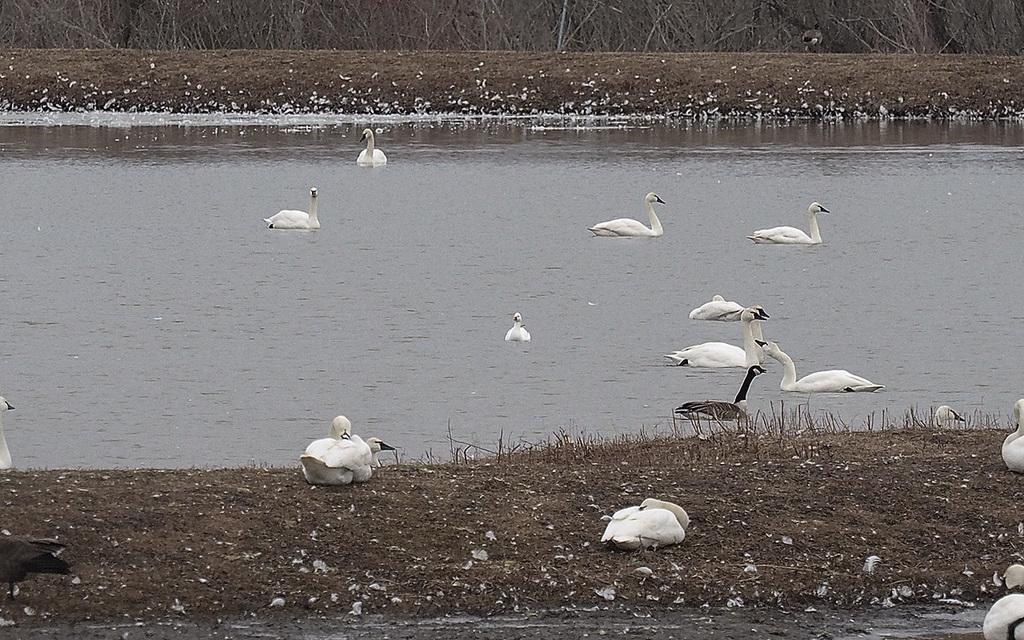In one or two sentences, can you explain what this image depicts? In this image I can see the birds which are in white and black color. I can see few birds are on the ground and few are in the water. In the background there are many dried plants. 